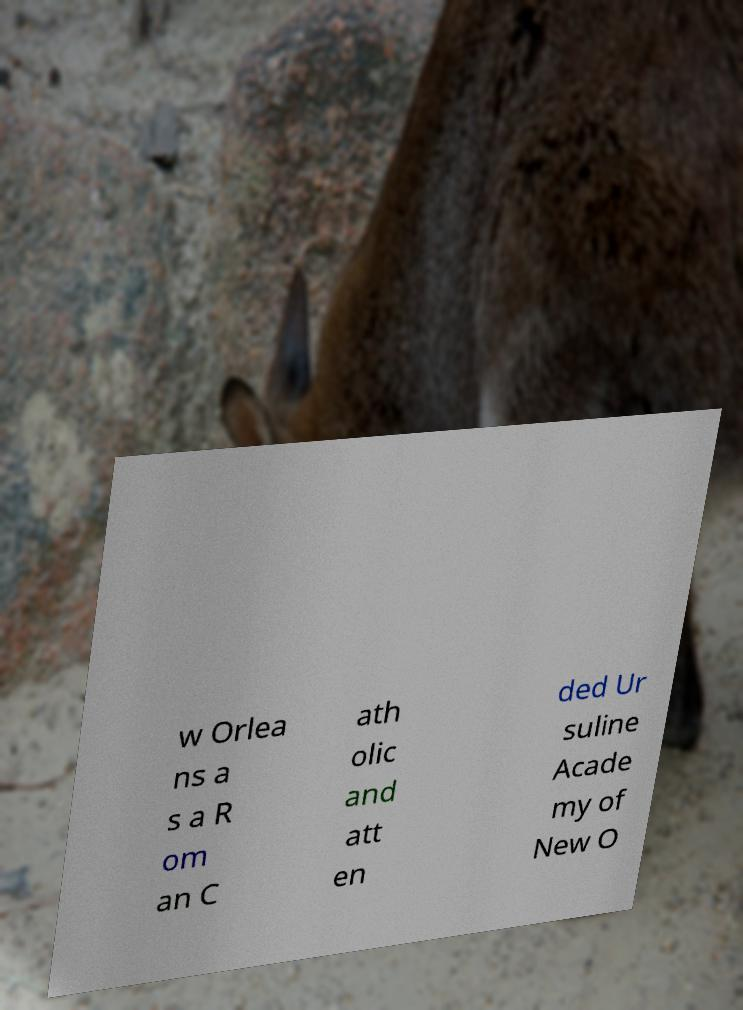For documentation purposes, I need the text within this image transcribed. Could you provide that? w Orlea ns a s a R om an C ath olic and att en ded Ur suline Acade my of New O 